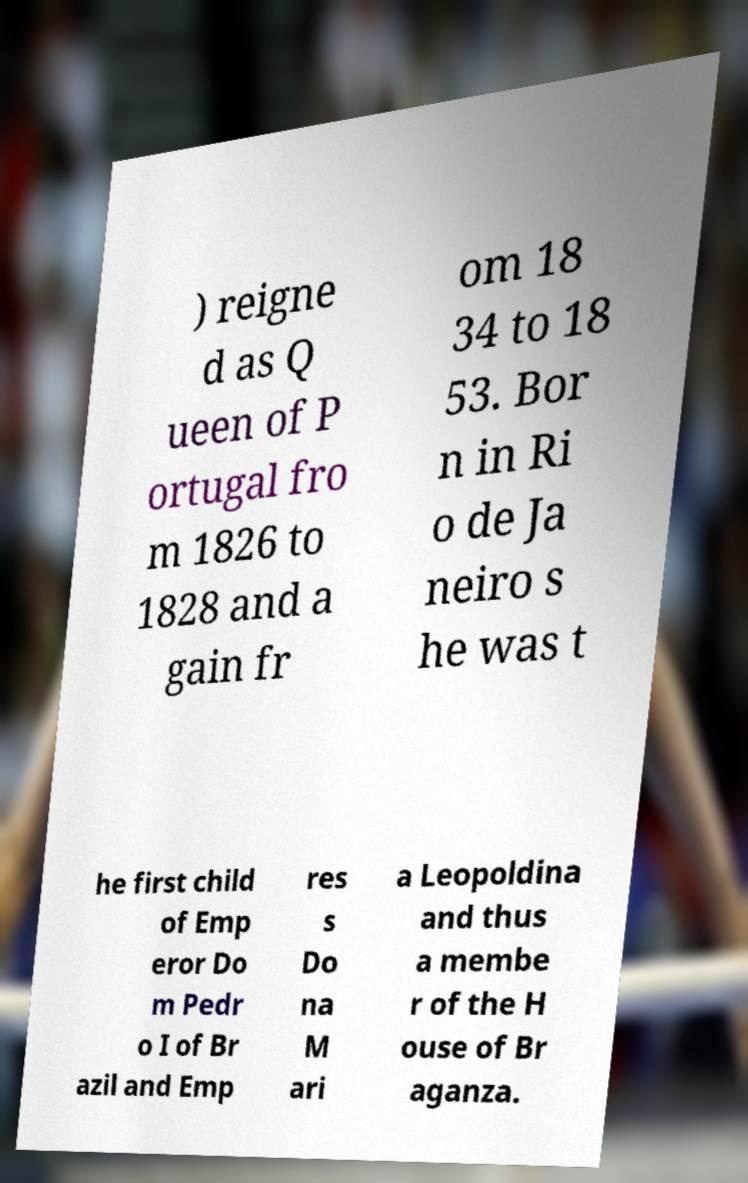Can you accurately transcribe the text from the provided image for me? ) reigne d as Q ueen of P ortugal fro m 1826 to 1828 and a gain fr om 18 34 to 18 53. Bor n in Ri o de Ja neiro s he was t he first child of Emp eror Do m Pedr o I of Br azil and Emp res s Do na M ari a Leopoldina and thus a membe r of the H ouse of Br aganza. 